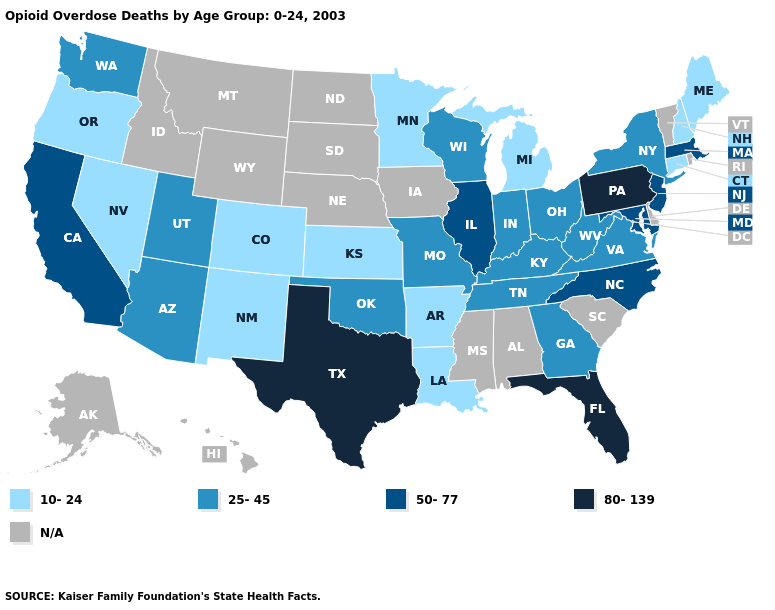What is the lowest value in the USA?
Be succinct. 10-24. Does New Jersey have the highest value in the Northeast?
Be succinct. No. Is the legend a continuous bar?
Quick response, please. No. Name the states that have a value in the range 80-139?
Write a very short answer. Florida, Pennsylvania, Texas. What is the value of Idaho?
Keep it brief. N/A. Which states have the highest value in the USA?
Answer briefly. Florida, Pennsylvania, Texas. What is the value of Ohio?
Answer briefly. 25-45. Which states have the lowest value in the USA?
Quick response, please. Arkansas, Colorado, Connecticut, Kansas, Louisiana, Maine, Michigan, Minnesota, Nevada, New Hampshire, New Mexico, Oregon. Does Florida have the highest value in the USA?
Short answer required. Yes. What is the value of Oklahoma?
Write a very short answer. 25-45. Is the legend a continuous bar?
Short answer required. No. Name the states that have a value in the range 25-45?
Give a very brief answer. Arizona, Georgia, Indiana, Kentucky, Missouri, New York, Ohio, Oklahoma, Tennessee, Utah, Virginia, Washington, West Virginia, Wisconsin. Does the first symbol in the legend represent the smallest category?
Write a very short answer. Yes. 